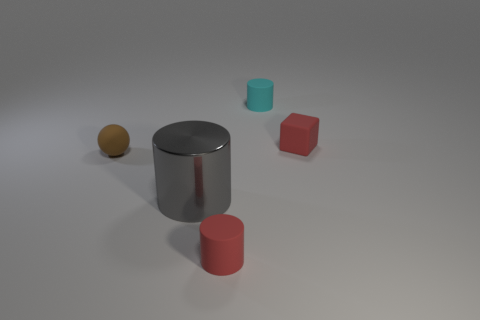Subtract all green cylinders. Subtract all red blocks. How many cylinders are left? 3 Add 2 tiny red balls. How many objects exist? 7 Subtract all cylinders. How many objects are left? 2 Subtract all yellow objects. Subtract all cubes. How many objects are left? 4 Add 5 cyan rubber cylinders. How many cyan rubber cylinders are left? 6 Add 1 red cubes. How many red cubes exist? 2 Subtract 0 yellow spheres. How many objects are left? 5 